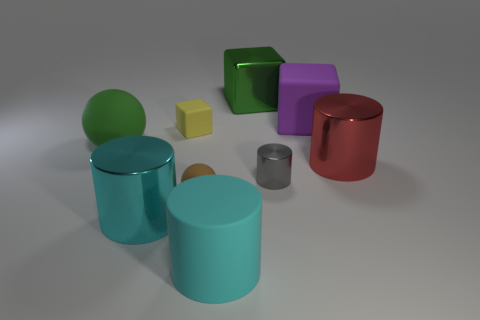Subtract all purple cubes. How many cubes are left? 2 Subtract all brown balls. How many balls are left? 1 Subtract 1 balls. How many balls are left? 1 Add 1 matte cubes. How many objects exist? 10 Subtract all brown cubes. How many red spheres are left? 0 Subtract all balls. How many objects are left? 7 Subtract all gray balls. Subtract all purple cubes. How many balls are left? 2 Subtract all large yellow rubber cylinders. Subtract all small metallic objects. How many objects are left? 8 Add 1 large rubber spheres. How many large rubber spheres are left? 2 Add 6 red metallic blocks. How many red metallic blocks exist? 6 